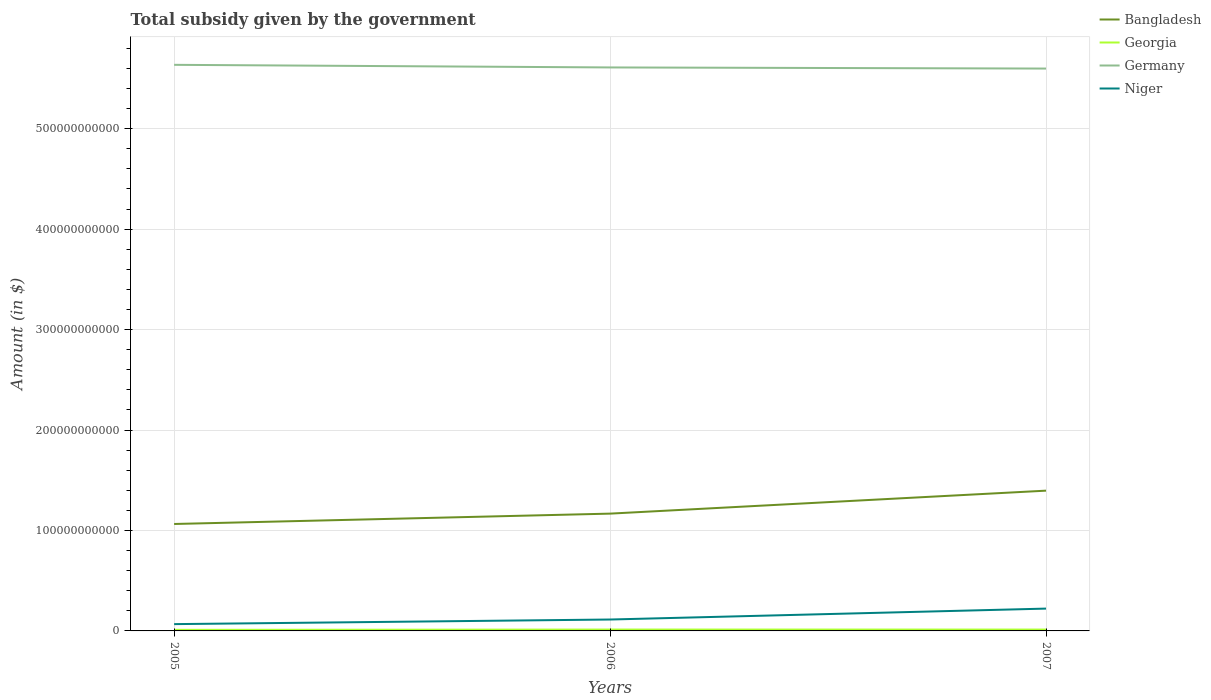Does the line corresponding to Georgia intersect with the line corresponding to Bangladesh?
Offer a very short reply. No. Across all years, what is the maximum total revenue collected by the government in Germany?
Keep it short and to the point. 5.60e+11. In which year was the total revenue collected by the government in Germany maximum?
Provide a short and direct response. 2007. What is the total total revenue collected by the government in Germany in the graph?
Provide a short and direct response. 2.60e+09. What is the difference between the highest and the second highest total revenue collected by the government in Germany?
Offer a terse response. 3.72e+09. What is the difference between the highest and the lowest total revenue collected by the government in Germany?
Keep it short and to the point. 1. Is the total revenue collected by the government in Niger strictly greater than the total revenue collected by the government in Georgia over the years?
Offer a terse response. No. How many lines are there?
Provide a short and direct response. 4. What is the difference between two consecutive major ticks on the Y-axis?
Your answer should be very brief. 1.00e+11. How many legend labels are there?
Your response must be concise. 4. How are the legend labels stacked?
Offer a terse response. Vertical. What is the title of the graph?
Ensure brevity in your answer.  Total subsidy given by the government. What is the label or title of the X-axis?
Keep it short and to the point. Years. What is the label or title of the Y-axis?
Your answer should be compact. Amount (in $). What is the Amount (in $) in Bangladesh in 2005?
Provide a succinct answer. 1.06e+11. What is the Amount (in $) of Georgia in 2005?
Give a very brief answer. 1.07e+09. What is the Amount (in $) of Germany in 2005?
Your answer should be very brief. 5.64e+11. What is the Amount (in $) in Niger in 2005?
Keep it short and to the point. 6.76e+09. What is the Amount (in $) of Bangladesh in 2006?
Your answer should be compact. 1.17e+11. What is the Amount (in $) of Georgia in 2006?
Offer a very short reply. 1.37e+09. What is the Amount (in $) of Germany in 2006?
Offer a terse response. 5.61e+11. What is the Amount (in $) in Niger in 2006?
Offer a very short reply. 1.14e+1. What is the Amount (in $) in Bangladesh in 2007?
Keep it short and to the point. 1.40e+11. What is the Amount (in $) of Georgia in 2007?
Your answer should be compact. 1.36e+09. What is the Amount (in $) of Germany in 2007?
Provide a succinct answer. 5.60e+11. What is the Amount (in $) of Niger in 2007?
Your answer should be compact. 2.22e+1. Across all years, what is the maximum Amount (in $) in Bangladesh?
Keep it short and to the point. 1.40e+11. Across all years, what is the maximum Amount (in $) in Georgia?
Your response must be concise. 1.37e+09. Across all years, what is the maximum Amount (in $) of Germany?
Keep it short and to the point. 5.64e+11. Across all years, what is the maximum Amount (in $) in Niger?
Your answer should be compact. 2.22e+1. Across all years, what is the minimum Amount (in $) in Bangladesh?
Your answer should be compact. 1.06e+11. Across all years, what is the minimum Amount (in $) of Georgia?
Provide a succinct answer. 1.07e+09. Across all years, what is the minimum Amount (in $) in Germany?
Provide a short and direct response. 5.60e+11. Across all years, what is the minimum Amount (in $) of Niger?
Offer a very short reply. 6.76e+09. What is the total Amount (in $) of Bangladesh in the graph?
Ensure brevity in your answer.  3.63e+11. What is the total Amount (in $) of Georgia in the graph?
Ensure brevity in your answer.  3.80e+09. What is the total Amount (in $) of Germany in the graph?
Keep it short and to the point. 1.68e+12. What is the total Amount (in $) of Niger in the graph?
Keep it short and to the point. 4.03e+1. What is the difference between the Amount (in $) in Bangladesh in 2005 and that in 2006?
Ensure brevity in your answer.  -1.03e+1. What is the difference between the Amount (in $) in Georgia in 2005 and that in 2006?
Give a very brief answer. -3.01e+08. What is the difference between the Amount (in $) in Germany in 2005 and that in 2006?
Your answer should be very brief. 2.60e+09. What is the difference between the Amount (in $) of Niger in 2005 and that in 2006?
Make the answer very short. -4.59e+09. What is the difference between the Amount (in $) in Bangladesh in 2005 and that in 2007?
Your answer should be very brief. -3.32e+1. What is the difference between the Amount (in $) in Georgia in 2005 and that in 2007?
Your answer should be compact. -2.88e+08. What is the difference between the Amount (in $) in Germany in 2005 and that in 2007?
Keep it short and to the point. 3.72e+09. What is the difference between the Amount (in $) of Niger in 2005 and that in 2007?
Make the answer very short. -1.55e+1. What is the difference between the Amount (in $) in Bangladesh in 2006 and that in 2007?
Provide a short and direct response. -2.29e+1. What is the difference between the Amount (in $) of Georgia in 2006 and that in 2007?
Keep it short and to the point. 1.25e+07. What is the difference between the Amount (in $) of Germany in 2006 and that in 2007?
Your answer should be compact. 1.12e+09. What is the difference between the Amount (in $) of Niger in 2006 and that in 2007?
Ensure brevity in your answer.  -1.09e+1. What is the difference between the Amount (in $) of Bangladesh in 2005 and the Amount (in $) of Georgia in 2006?
Make the answer very short. 1.05e+11. What is the difference between the Amount (in $) of Bangladesh in 2005 and the Amount (in $) of Germany in 2006?
Provide a short and direct response. -4.55e+11. What is the difference between the Amount (in $) in Bangladesh in 2005 and the Amount (in $) in Niger in 2006?
Your answer should be very brief. 9.51e+1. What is the difference between the Amount (in $) of Georgia in 2005 and the Amount (in $) of Germany in 2006?
Offer a terse response. -5.60e+11. What is the difference between the Amount (in $) in Georgia in 2005 and the Amount (in $) in Niger in 2006?
Your answer should be very brief. -1.03e+1. What is the difference between the Amount (in $) in Germany in 2005 and the Amount (in $) in Niger in 2006?
Offer a very short reply. 5.52e+11. What is the difference between the Amount (in $) in Bangladesh in 2005 and the Amount (in $) in Georgia in 2007?
Provide a short and direct response. 1.05e+11. What is the difference between the Amount (in $) in Bangladesh in 2005 and the Amount (in $) in Germany in 2007?
Your response must be concise. -4.53e+11. What is the difference between the Amount (in $) in Bangladesh in 2005 and the Amount (in $) in Niger in 2007?
Provide a succinct answer. 8.42e+1. What is the difference between the Amount (in $) of Georgia in 2005 and the Amount (in $) of Germany in 2007?
Provide a short and direct response. -5.59e+11. What is the difference between the Amount (in $) in Georgia in 2005 and the Amount (in $) in Niger in 2007?
Make the answer very short. -2.12e+1. What is the difference between the Amount (in $) of Germany in 2005 and the Amount (in $) of Niger in 2007?
Your answer should be compact. 5.41e+11. What is the difference between the Amount (in $) of Bangladesh in 2006 and the Amount (in $) of Georgia in 2007?
Keep it short and to the point. 1.15e+11. What is the difference between the Amount (in $) of Bangladesh in 2006 and the Amount (in $) of Germany in 2007?
Provide a short and direct response. -4.43e+11. What is the difference between the Amount (in $) in Bangladesh in 2006 and the Amount (in $) in Niger in 2007?
Give a very brief answer. 9.46e+1. What is the difference between the Amount (in $) of Georgia in 2006 and the Amount (in $) of Germany in 2007?
Offer a very short reply. -5.58e+11. What is the difference between the Amount (in $) in Georgia in 2006 and the Amount (in $) in Niger in 2007?
Your response must be concise. -2.09e+1. What is the difference between the Amount (in $) in Germany in 2006 and the Amount (in $) in Niger in 2007?
Provide a short and direct response. 5.39e+11. What is the average Amount (in $) of Bangladesh per year?
Provide a succinct answer. 1.21e+11. What is the average Amount (in $) in Georgia per year?
Keep it short and to the point. 1.27e+09. What is the average Amount (in $) of Germany per year?
Offer a very short reply. 5.61e+11. What is the average Amount (in $) in Niger per year?
Offer a terse response. 1.34e+1. In the year 2005, what is the difference between the Amount (in $) in Bangladesh and Amount (in $) in Georgia?
Keep it short and to the point. 1.05e+11. In the year 2005, what is the difference between the Amount (in $) of Bangladesh and Amount (in $) of Germany?
Provide a succinct answer. -4.57e+11. In the year 2005, what is the difference between the Amount (in $) in Bangladesh and Amount (in $) in Niger?
Offer a very short reply. 9.97e+1. In the year 2005, what is the difference between the Amount (in $) of Georgia and Amount (in $) of Germany?
Provide a short and direct response. -5.63e+11. In the year 2005, what is the difference between the Amount (in $) of Georgia and Amount (in $) of Niger?
Provide a succinct answer. -5.69e+09. In the year 2005, what is the difference between the Amount (in $) of Germany and Amount (in $) of Niger?
Offer a terse response. 5.57e+11. In the year 2006, what is the difference between the Amount (in $) of Bangladesh and Amount (in $) of Georgia?
Your response must be concise. 1.15e+11. In the year 2006, what is the difference between the Amount (in $) in Bangladesh and Amount (in $) in Germany?
Offer a terse response. -4.44e+11. In the year 2006, what is the difference between the Amount (in $) in Bangladesh and Amount (in $) in Niger?
Make the answer very short. 1.05e+11. In the year 2006, what is the difference between the Amount (in $) in Georgia and Amount (in $) in Germany?
Your answer should be very brief. -5.60e+11. In the year 2006, what is the difference between the Amount (in $) of Georgia and Amount (in $) of Niger?
Make the answer very short. -9.98e+09. In the year 2006, what is the difference between the Amount (in $) of Germany and Amount (in $) of Niger?
Ensure brevity in your answer.  5.50e+11. In the year 2007, what is the difference between the Amount (in $) in Bangladesh and Amount (in $) in Georgia?
Provide a succinct answer. 1.38e+11. In the year 2007, what is the difference between the Amount (in $) of Bangladesh and Amount (in $) of Germany?
Give a very brief answer. -4.20e+11. In the year 2007, what is the difference between the Amount (in $) in Bangladesh and Amount (in $) in Niger?
Make the answer very short. 1.17e+11. In the year 2007, what is the difference between the Amount (in $) in Georgia and Amount (in $) in Germany?
Give a very brief answer. -5.58e+11. In the year 2007, what is the difference between the Amount (in $) of Georgia and Amount (in $) of Niger?
Your response must be concise. -2.09e+1. In the year 2007, what is the difference between the Amount (in $) of Germany and Amount (in $) of Niger?
Provide a succinct answer. 5.38e+11. What is the ratio of the Amount (in $) of Bangladesh in 2005 to that in 2006?
Give a very brief answer. 0.91. What is the ratio of the Amount (in $) of Georgia in 2005 to that in 2006?
Give a very brief answer. 0.78. What is the ratio of the Amount (in $) in Germany in 2005 to that in 2006?
Offer a very short reply. 1. What is the ratio of the Amount (in $) in Niger in 2005 to that in 2006?
Offer a very short reply. 0.6. What is the ratio of the Amount (in $) of Bangladesh in 2005 to that in 2007?
Provide a short and direct response. 0.76. What is the ratio of the Amount (in $) of Georgia in 2005 to that in 2007?
Your response must be concise. 0.79. What is the ratio of the Amount (in $) of Germany in 2005 to that in 2007?
Your answer should be compact. 1.01. What is the ratio of the Amount (in $) of Niger in 2005 to that in 2007?
Keep it short and to the point. 0.3. What is the ratio of the Amount (in $) in Bangladesh in 2006 to that in 2007?
Offer a very short reply. 0.84. What is the ratio of the Amount (in $) of Georgia in 2006 to that in 2007?
Offer a very short reply. 1.01. What is the ratio of the Amount (in $) of Niger in 2006 to that in 2007?
Your answer should be very brief. 0.51. What is the difference between the highest and the second highest Amount (in $) of Bangladesh?
Keep it short and to the point. 2.29e+1. What is the difference between the highest and the second highest Amount (in $) of Georgia?
Your answer should be compact. 1.25e+07. What is the difference between the highest and the second highest Amount (in $) of Germany?
Ensure brevity in your answer.  2.60e+09. What is the difference between the highest and the second highest Amount (in $) of Niger?
Provide a succinct answer. 1.09e+1. What is the difference between the highest and the lowest Amount (in $) in Bangladesh?
Give a very brief answer. 3.32e+1. What is the difference between the highest and the lowest Amount (in $) of Georgia?
Ensure brevity in your answer.  3.01e+08. What is the difference between the highest and the lowest Amount (in $) in Germany?
Give a very brief answer. 3.72e+09. What is the difference between the highest and the lowest Amount (in $) in Niger?
Make the answer very short. 1.55e+1. 